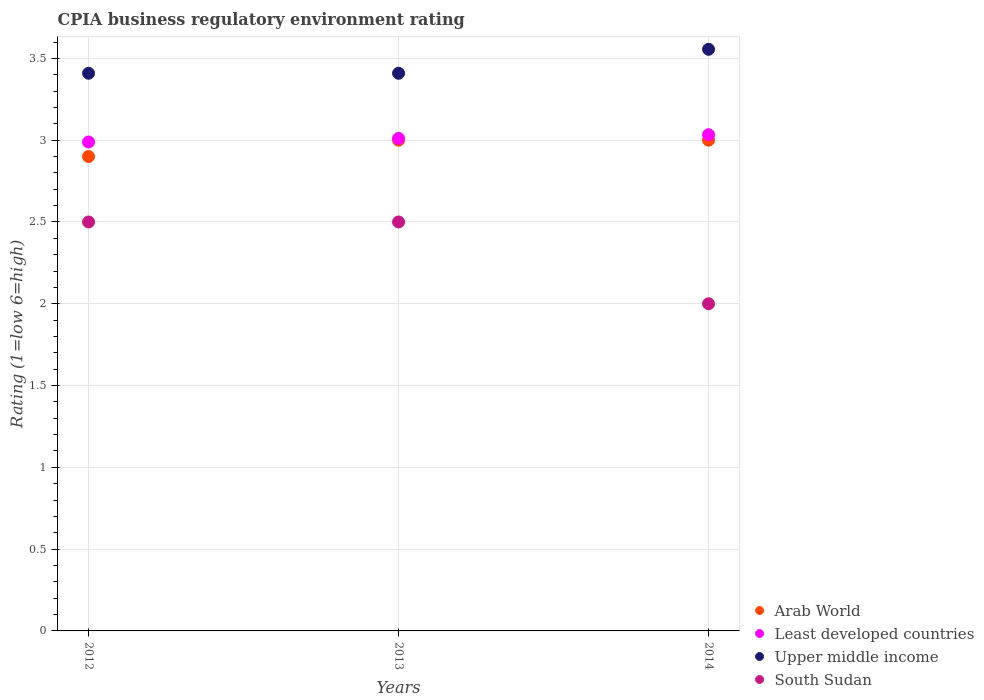Is the number of dotlines equal to the number of legend labels?
Your answer should be compact. Yes. What is the CPIA rating in Upper middle income in 2014?
Offer a very short reply. 3.56. Across all years, what is the maximum CPIA rating in Arab World?
Ensure brevity in your answer.  3. Across all years, what is the minimum CPIA rating in South Sudan?
Your answer should be very brief. 2. In which year was the CPIA rating in South Sudan maximum?
Your response must be concise. 2012. In which year was the CPIA rating in South Sudan minimum?
Your answer should be compact. 2014. What is the total CPIA rating in Upper middle income in the graph?
Make the answer very short. 10.37. What is the difference between the CPIA rating in Least developed countries in 2012 and that in 2014?
Offer a terse response. -0.04. What is the average CPIA rating in South Sudan per year?
Ensure brevity in your answer.  2.33. In the year 2014, what is the difference between the CPIA rating in Upper middle income and CPIA rating in Least developed countries?
Make the answer very short. 0.52. In how many years, is the CPIA rating in Arab World greater than 1.7?
Your answer should be compact. 3. What is the ratio of the CPIA rating in Least developed countries in 2013 to that in 2014?
Keep it short and to the point. 0.99. Is the CPIA rating in Arab World in 2012 less than that in 2014?
Provide a short and direct response. Yes. Is the difference between the CPIA rating in Upper middle income in 2013 and 2014 greater than the difference between the CPIA rating in Least developed countries in 2013 and 2014?
Make the answer very short. No. What is the difference between the highest and the second highest CPIA rating in Least developed countries?
Give a very brief answer. 0.02. What is the difference between the highest and the lowest CPIA rating in Least developed countries?
Keep it short and to the point. 0.04. In how many years, is the CPIA rating in Arab World greater than the average CPIA rating in Arab World taken over all years?
Your answer should be very brief. 2. Is it the case that in every year, the sum of the CPIA rating in Arab World and CPIA rating in Upper middle income  is greater than the CPIA rating in South Sudan?
Offer a terse response. Yes. Does the CPIA rating in Least developed countries monotonically increase over the years?
Your answer should be compact. Yes. Is the CPIA rating in South Sudan strictly less than the CPIA rating in Least developed countries over the years?
Ensure brevity in your answer.  Yes. How many dotlines are there?
Keep it short and to the point. 4. How many years are there in the graph?
Give a very brief answer. 3. What is the difference between two consecutive major ticks on the Y-axis?
Offer a terse response. 0.5. Are the values on the major ticks of Y-axis written in scientific E-notation?
Offer a very short reply. No. Does the graph contain grids?
Your answer should be compact. Yes. Where does the legend appear in the graph?
Your response must be concise. Bottom right. How are the legend labels stacked?
Offer a terse response. Vertical. What is the title of the graph?
Provide a succinct answer. CPIA business regulatory environment rating. Does "Oman" appear as one of the legend labels in the graph?
Ensure brevity in your answer.  No. What is the label or title of the X-axis?
Give a very brief answer. Years. What is the Rating (1=low 6=high) of Arab World in 2012?
Give a very brief answer. 2.9. What is the Rating (1=low 6=high) of Least developed countries in 2012?
Your response must be concise. 2.99. What is the Rating (1=low 6=high) of Upper middle income in 2012?
Your response must be concise. 3.41. What is the Rating (1=low 6=high) in Least developed countries in 2013?
Ensure brevity in your answer.  3.01. What is the Rating (1=low 6=high) in Upper middle income in 2013?
Give a very brief answer. 3.41. What is the Rating (1=low 6=high) of Least developed countries in 2014?
Your answer should be compact. 3.03. What is the Rating (1=low 6=high) in Upper middle income in 2014?
Your response must be concise. 3.56. Across all years, what is the maximum Rating (1=low 6=high) in Arab World?
Make the answer very short. 3. Across all years, what is the maximum Rating (1=low 6=high) in Least developed countries?
Keep it short and to the point. 3.03. Across all years, what is the maximum Rating (1=low 6=high) of Upper middle income?
Provide a succinct answer. 3.56. Across all years, what is the maximum Rating (1=low 6=high) in South Sudan?
Your answer should be compact. 2.5. Across all years, what is the minimum Rating (1=low 6=high) of Least developed countries?
Provide a succinct answer. 2.99. Across all years, what is the minimum Rating (1=low 6=high) in Upper middle income?
Your answer should be compact. 3.41. What is the total Rating (1=low 6=high) of Least developed countries in the graph?
Your response must be concise. 9.03. What is the total Rating (1=low 6=high) of Upper middle income in the graph?
Give a very brief answer. 10.37. What is the difference between the Rating (1=low 6=high) in Arab World in 2012 and that in 2013?
Your answer should be compact. -0.1. What is the difference between the Rating (1=low 6=high) in Least developed countries in 2012 and that in 2013?
Your answer should be very brief. -0.02. What is the difference between the Rating (1=low 6=high) of Upper middle income in 2012 and that in 2013?
Your answer should be very brief. 0. What is the difference between the Rating (1=low 6=high) in South Sudan in 2012 and that in 2013?
Give a very brief answer. 0. What is the difference between the Rating (1=low 6=high) of Arab World in 2012 and that in 2014?
Your answer should be very brief. -0.1. What is the difference between the Rating (1=low 6=high) of Least developed countries in 2012 and that in 2014?
Provide a succinct answer. -0.04. What is the difference between the Rating (1=low 6=high) in Upper middle income in 2012 and that in 2014?
Offer a terse response. -0.15. What is the difference between the Rating (1=low 6=high) of Least developed countries in 2013 and that in 2014?
Keep it short and to the point. -0.02. What is the difference between the Rating (1=low 6=high) in Upper middle income in 2013 and that in 2014?
Your response must be concise. -0.15. What is the difference between the Rating (1=low 6=high) of South Sudan in 2013 and that in 2014?
Ensure brevity in your answer.  0.5. What is the difference between the Rating (1=low 6=high) of Arab World in 2012 and the Rating (1=low 6=high) of Least developed countries in 2013?
Your answer should be compact. -0.11. What is the difference between the Rating (1=low 6=high) of Arab World in 2012 and the Rating (1=low 6=high) of Upper middle income in 2013?
Offer a very short reply. -0.51. What is the difference between the Rating (1=low 6=high) in Least developed countries in 2012 and the Rating (1=low 6=high) in Upper middle income in 2013?
Offer a terse response. -0.42. What is the difference between the Rating (1=low 6=high) in Least developed countries in 2012 and the Rating (1=low 6=high) in South Sudan in 2013?
Provide a succinct answer. 0.49. What is the difference between the Rating (1=low 6=high) of Arab World in 2012 and the Rating (1=low 6=high) of Least developed countries in 2014?
Make the answer very short. -0.13. What is the difference between the Rating (1=low 6=high) of Arab World in 2012 and the Rating (1=low 6=high) of Upper middle income in 2014?
Your response must be concise. -0.66. What is the difference between the Rating (1=low 6=high) in Arab World in 2012 and the Rating (1=low 6=high) in South Sudan in 2014?
Make the answer very short. 0.9. What is the difference between the Rating (1=low 6=high) in Least developed countries in 2012 and the Rating (1=low 6=high) in Upper middle income in 2014?
Give a very brief answer. -0.57. What is the difference between the Rating (1=low 6=high) of Least developed countries in 2012 and the Rating (1=low 6=high) of South Sudan in 2014?
Ensure brevity in your answer.  0.99. What is the difference between the Rating (1=low 6=high) in Upper middle income in 2012 and the Rating (1=low 6=high) in South Sudan in 2014?
Your response must be concise. 1.41. What is the difference between the Rating (1=low 6=high) in Arab World in 2013 and the Rating (1=low 6=high) in Least developed countries in 2014?
Ensure brevity in your answer.  -0.03. What is the difference between the Rating (1=low 6=high) of Arab World in 2013 and the Rating (1=low 6=high) of Upper middle income in 2014?
Ensure brevity in your answer.  -0.56. What is the difference between the Rating (1=low 6=high) of Least developed countries in 2013 and the Rating (1=low 6=high) of Upper middle income in 2014?
Provide a short and direct response. -0.54. What is the difference between the Rating (1=low 6=high) in Least developed countries in 2013 and the Rating (1=low 6=high) in South Sudan in 2014?
Offer a terse response. 1.01. What is the difference between the Rating (1=low 6=high) in Upper middle income in 2013 and the Rating (1=low 6=high) in South Sudan in 2014?
Keep it short and to the point. 1.41. What is the average Rating (1=low 6=high) of Arab World per year?
Offer a very short reply. 2.97. What is the average Rating (1=low 6=high) of Least developed countries per year?
Your response must be concise. 3.01. What is the average Rating (1=low 6=high) in Upper middle income per year?
Offer a very short reply. 3.46. What is the average Rating (1=low 6=high) of South Sudan per year?
Keep it short and to the point. 2.33. In the year 2012, what is the difference between the Rating (1=low 6=high) of Arab World and Rating (1=low 6=high) of Least developed countries?
Your response must be concise. -0.09. In the year 2012, what is the difference between the Rating (1=low 6=high) of Arab World and Rating (1=low 6=high) of Upper middle income?
Your response must be concise. -0.51. In the year 2012, what is the difference between the Rating (1=low 6=high) in Least developed countries and Rating (1=low 6=high) in Upper middle income?
Make the answer very short. -0.42. In the year 2012, what is the difference between the Rating (1=low 6=high) in Least developed countries and Rating (1=low 6=high) in South Sudan?
Offer a terse response. 0.49. In the year 2012, what is the difference between the Rating (1=low 6=high) of Upper middle income and Rating (1=low 6=high) of South Sudan?
Make the answer very short. 0.91. In the year 2013, what is the difference between the Rating (1=low 6=high) in Arab World and Rating (1=low 6=high) in Least developed countries?
Your answer should be compact. -0.01. In the year 2013, what is the difference between the Rating (1=low 6=high) in Arab World and Rating (1=low 6=high) in Upper middle income?
Provide a short and direct response. -0.41. In the year 2013, what is the difference between the Rating (1=low 6=high) in Least developed countries and Rating (1=low 6=high) in Upper middle income?
Give a very brief answer. -0.4. In the year 2013, what is the difference between the Rating (1=low 6=high) in Least developed countries and Rating (1=low 6=high) in South Sudan?
Give a very brief answer. 0.51. In the year 2014, what is the difference between the Rating (1=low 6=high) of Arab World and Rating (1=low 6=high) of Least developed countries?
Ensure brevity in your answer.  -0.03. In the year 2014, what is the difference between the Rating (1=low 6=high) in Arab World and Rating (1=low 6=high) in Upper middle income?
Offer a very short reply. -0.56. In the year 2014, what is the difference between the Rating (1=low 6=high) in Arab World and Rating (1=low 6=high) in South Sudan?
Ensure brevity in your answer.  1. In the year 2014, what is the difference between the Rating (1=low 6=high) in Least developed countries and Rating (1=low 6=high) in Upper middle income?
Give a very brief answer. -0.52. In the year 2014, what is the difference between the Rating (1=low 6=high) in Least developed countries and Rating (1=low 6=high) in South Sudan?
Provide a short and direct response. 1.03. In the year 2014, what is the difference between the Rating (1=low 6=high) of Upper middle income and Rating (1=low 6=high) of South Sudan?
Offer a very short reply. 1.56. What is the ratio of the Rating (1=low 6=high) of Arab World in 2012 to that in 2013?
Your answer should be very brief. 0.97. What is the ratio of the Rating (1=low 6=high) in Upper middle income in 2012 to that in 2013?
Offer a very short reply. 1. What is the ratio of the Rating (1=low 6=high) in South Sudan in 2012 to that in 2013?
Make the answer very short. 1. What is the ratio of the Rating (1=low 6=high) of Arab World in 2012 to that in 2014?
Offer a very short reply. 0.97. What is the ratio of the Rating (1=low 6=high) in Least developed countries in 2012 to that in 2014?
Ensure brevity in your answer.  0.99. What is the ratio of the Rating (1=low 6=high) in Upper middle income in 2012 to that in 2014?
Keep it short and to the point. 0.96. What is the ratio of the Rating (1=low 6=high) in Upper middle income in 2013 to that in 2014?
Provide a short and direct response. 0.96. What is the ratio of the Rating (1=low 6=high) in South Sudan in 2013 to that in 2014?
Your answer should be very brief. 1.25. What is the difference between the highest and the second highest Rating (1=low 6=high) of Least developed countries?
Provide a succinct answer. 0.02. What is the difference between the highest and the second highest Rating (1=low 6=high) in Upper middle income?
Make the answer very short. 0.15. What is the difference between the highest and the second highest Rating (1=low 6=high) of South Sudan?
Your response must be concise. 0. What is the difference between the highest and the lowest Rating (1=low 6=high) of Arab World?
Offer a terse response. 0.1. What is the difference between the highest and the lowest Rating (1=low 6=high) of Least developed countries?
Offer a terse response. 0.04. What is the difference between the highest and the lowest Rating (1=low 6=high) of Upper middle income?
Give a very brief answer. 0.15. What is the difference between the highest and the lowest Rating (1=low 6=high) in South Sudan?
Your answer should be compact. 0.5. 